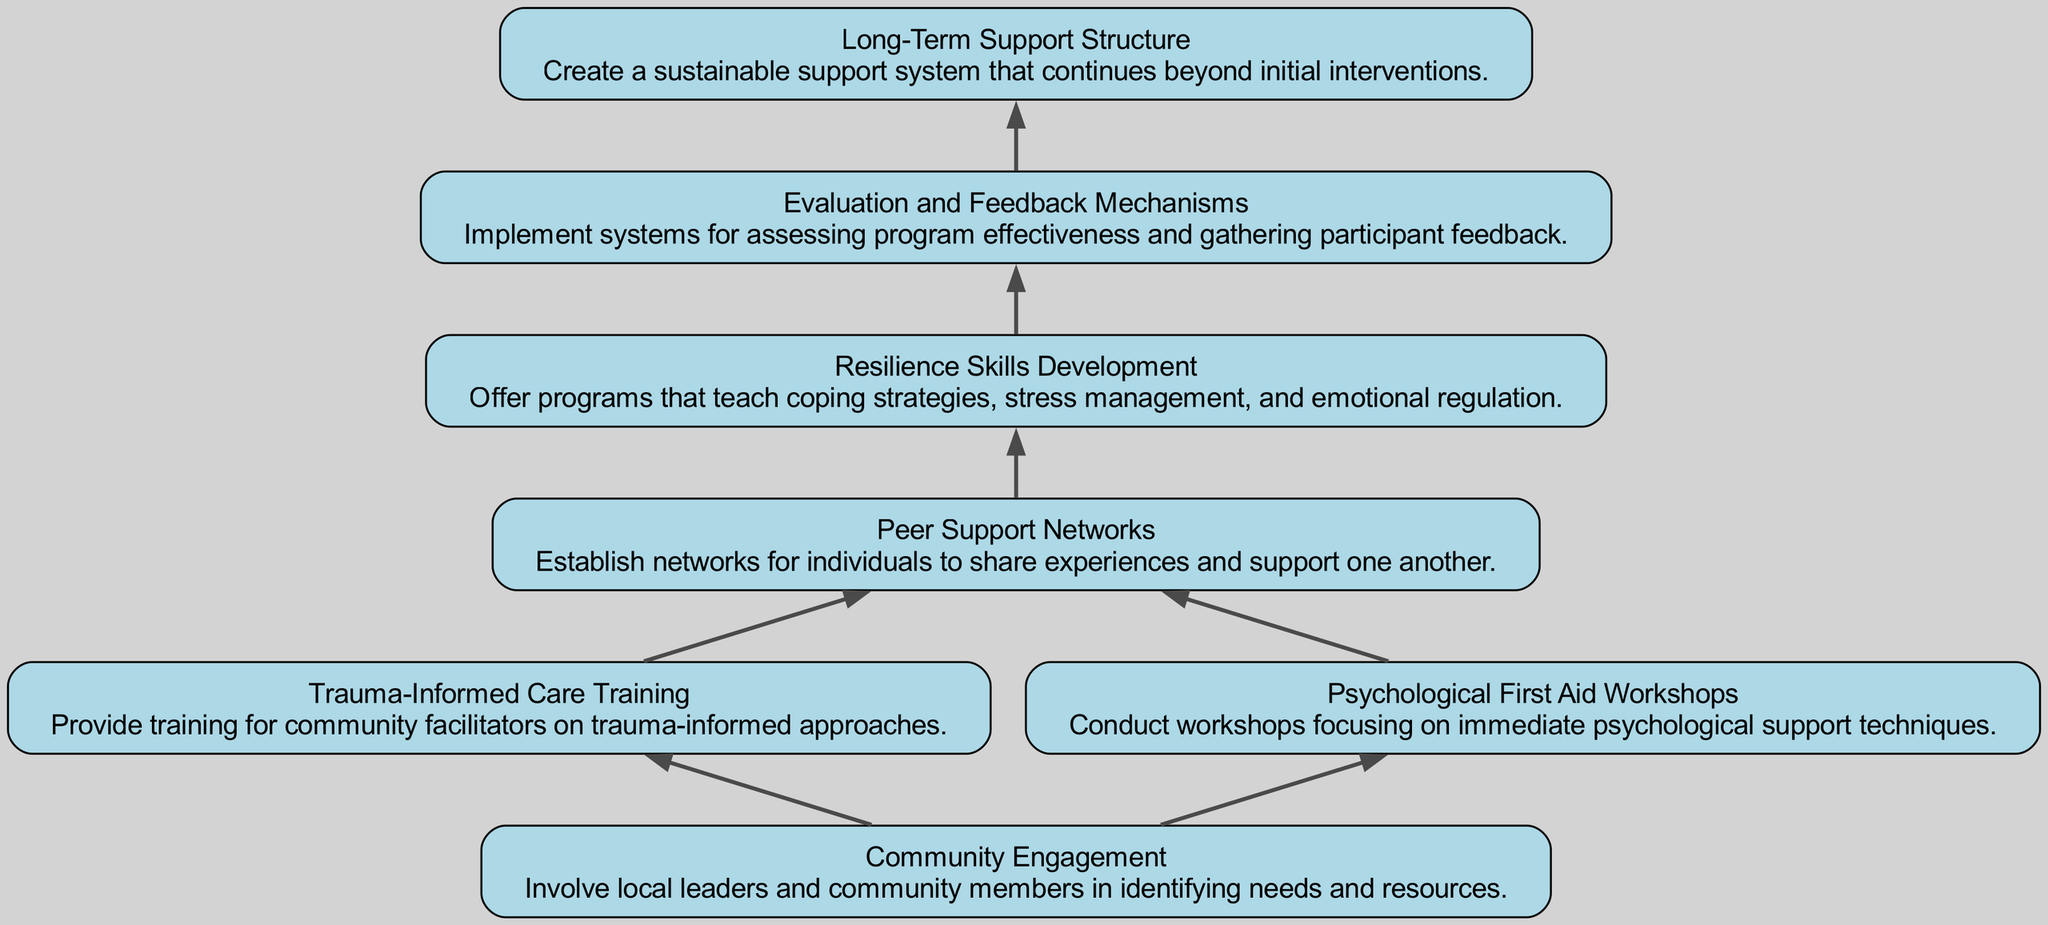What is the first node in the diagram? The diagram starts with the "Community Engagement" node, which is the bottom-most node before others branch out. Since this is a bottom-up flow chart, the first node represents the foundational step.
Answer: Community Engagement How many total nodes are there in the diagram? The diagram includes seven nodes: Community Engagement, Trauma-Informed Care Training, Psychological First Aid Workshops, Peer Support Networks, Resilience Skills Development, Evaluation and Feedback Mechanisms, and Long-Term Support Structure. Adding them all gives a total of seven nodes.
Answer: 7 Which nodes directly connect to “Community Engagement”? The "Community Engagement" node directly connects to two nodes: "Trauma-Informed Care Training" and "Psychological First Aid Workshops." They represent strategies that emerge from community involvement.
Answer: Trauma-Informed Care Training, Psychological First Aid Workshops What is the relationship between "Peer Support Networks" and "Resilience Skills Development"? "Peer Support Networks" feeds into "Resilience Skills Development," meaning that establishing peer networks leads into programming that develops resilience skills. This progression indicates how shared experiences lead to learning coping strategies.
Answer: Peer Support Networks → Resilience Skills Development How does "Evaluation and Feedback Mechanisms" contribute to the diagram's structure? "Evaluation and Feedback Mechanisms" is positioned to assess the effectiveness of prior steps, particularly following "Resilience Skills Development." This positioning emphasizes the importance of continuously improving the support programs based on actual feedback.
Answer: Continuous improvement What is the expected outcome of the program development process? The final node is "Long-Term Support Structure," which represents the overarching expected outcome of establishing sustainable community support. This provides a final goal for all preceding actions.
Answer: Long-Term Support Structure Which two strategies involve immediate psychological support? "Psychological First Aid Workshops" and "Trauma-Informed Care Training" both provide immediate psychological support techniques directly to the community members affected. These workshops focus on the immediate needs in crisis situations.
Answer: Psychological First Aid Workshops, Trauma-Informed Care Training What is the last node in the flow chart? The final node at the top of the chart is "Long-Term Support Structure." It signifies the ultimate goal of creating a sustainable system of support that extends beyond initial interventions to ensure lasting psychological resilience in communities.
Answer: Long-Term Support Structure 